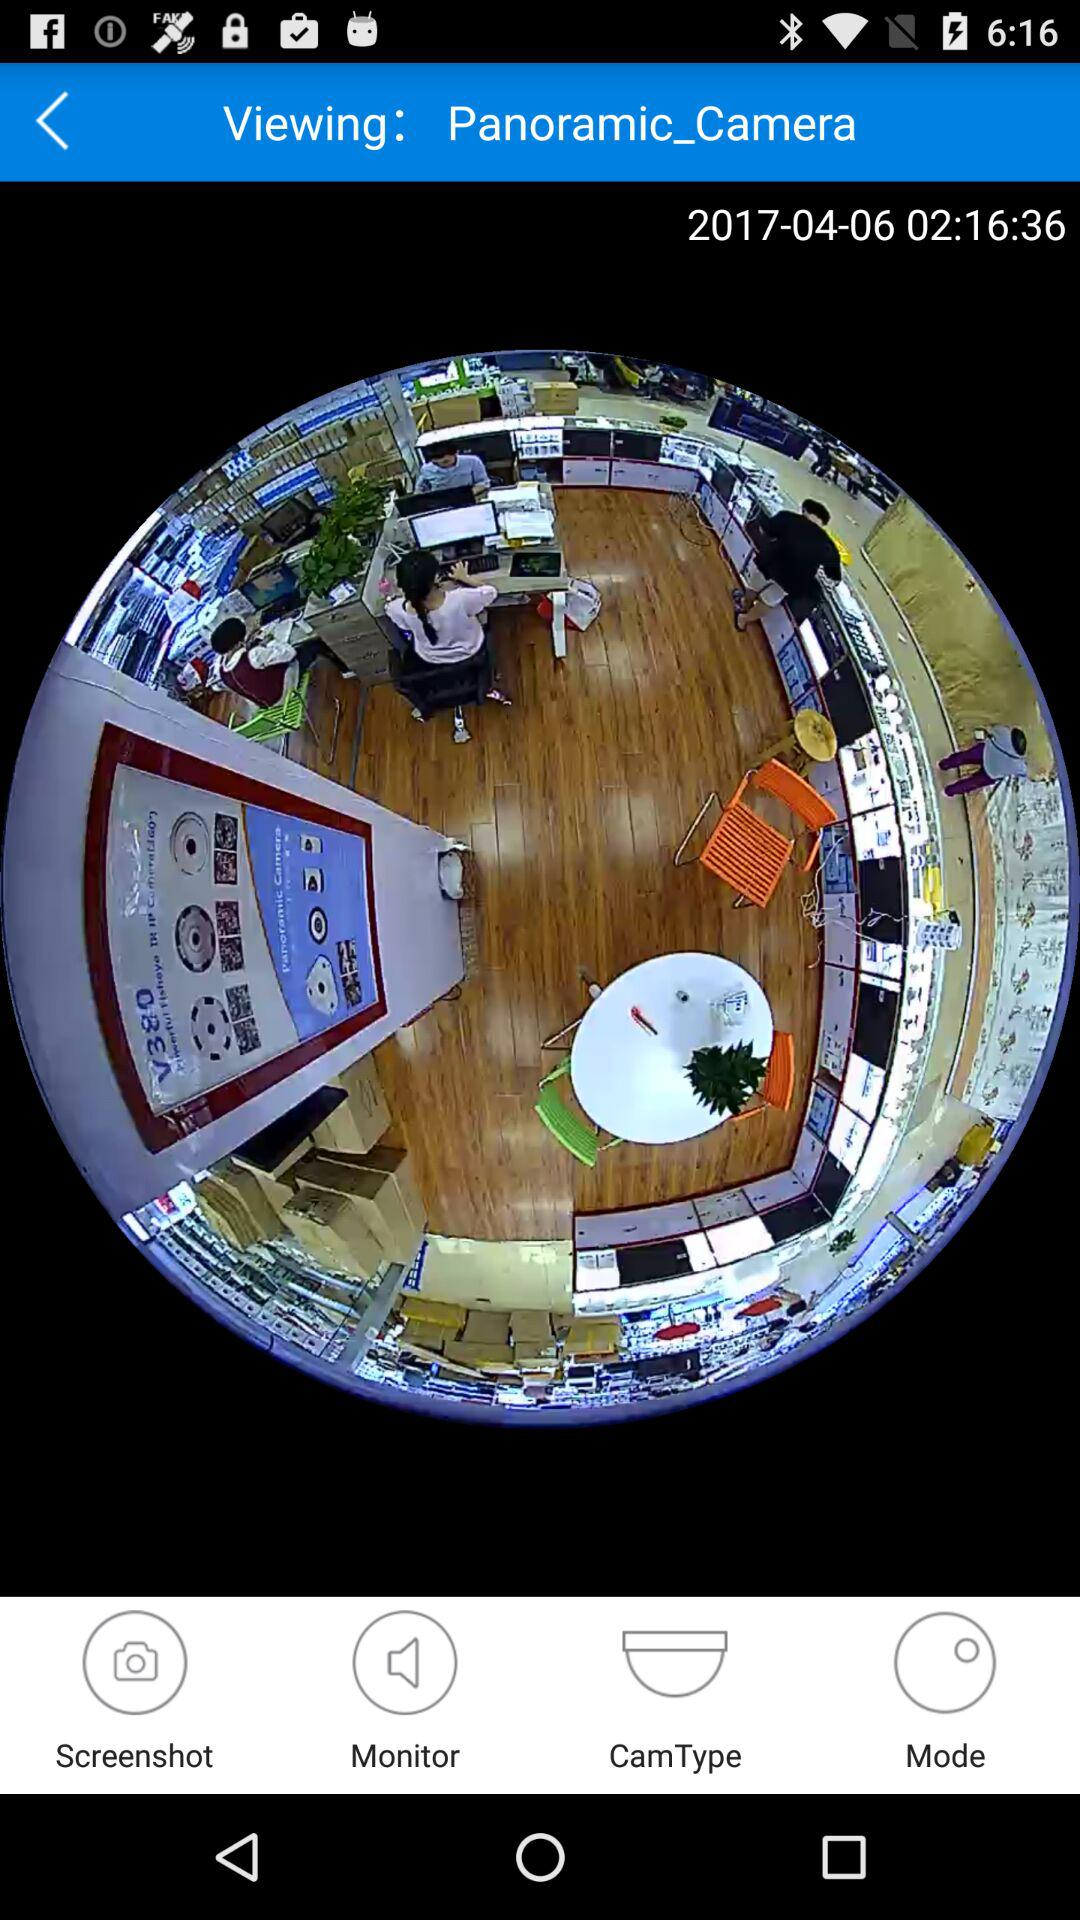What's the date and time? The date and time are April 6, 2017 and 02:16:36, respectively. 